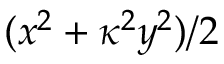Convert formula to latex. <formula><loc_0><loc_0><loc_500><loc_500>( x ^ { 2 } + \kappa ^ { 2 } y ^ { 2 } ) / 2</formula> 